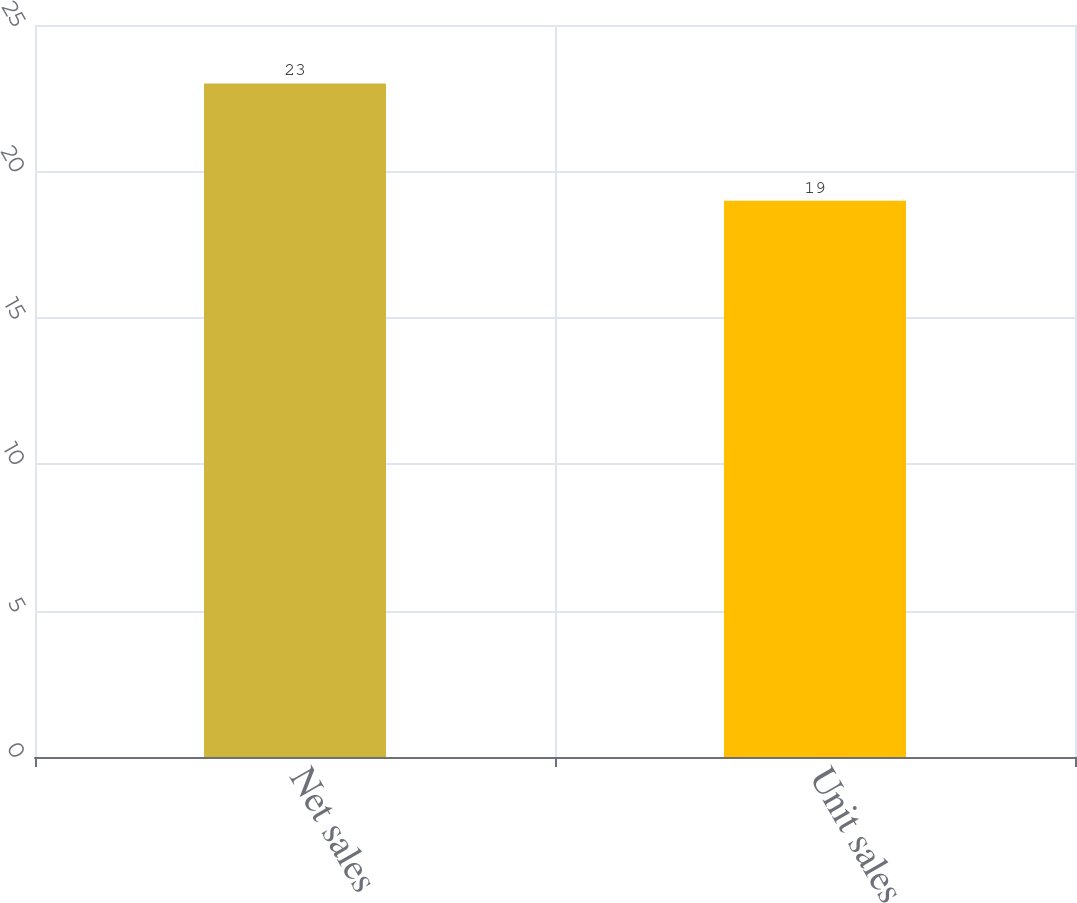Convert chart. <chart><loc_0><loc_0><loc_500><loc_500><bar_chart><fcel>Net sales<fcel>Unit sales<nl><fcel>23<fcel>19<nl></chart> 